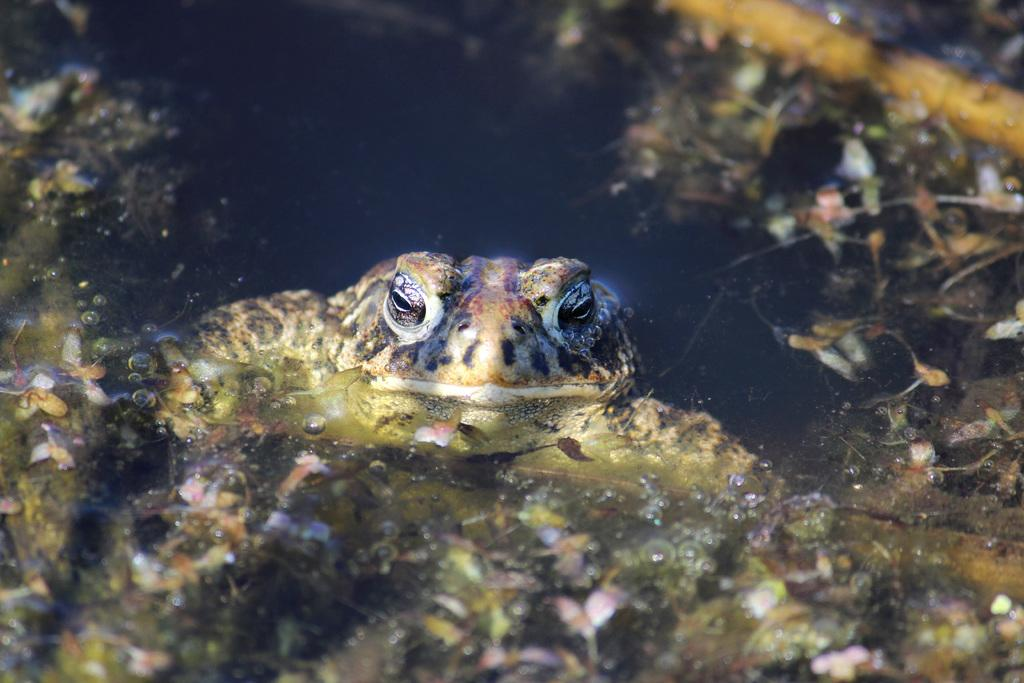What animal is present in the image? There is a frog in the image. Where is the frog located? The frog is in the water. What else can be seen floating on the water in the image? There are dry leaves on the water in the image. What type of machine is visible in the image? There is no machine present in the image; it features a frog in the water with dry leaves. 